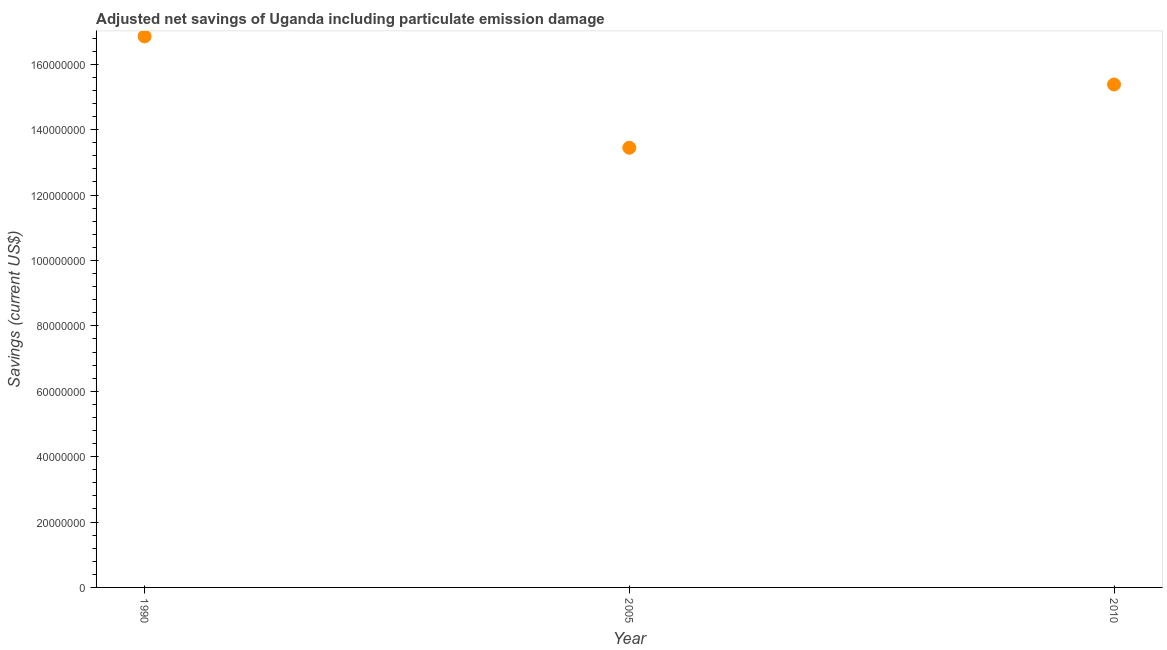What is the adjusted net savings in 2010?
Your answer should be very brief. 1.54e+08. Across all years, what is the maximum adjusted net savings?
Offer a very short reply. 1.69e+08. Across all years, what is the minimum adjusted net savings?
Your answer should be compact. 1.34e+08. In which year was the adjusted net savings minimum?
Keep it short and to the point. 2005. What is the sum of the adjusted net savings?
Your response must be concise. 4.57e+08. What is the difference between the adjusted net savings in 1990 and 2010?
Keep it short and to the point. 1.47e+07. What is the average adjusted net savings per year?
Your answer should be very brief. 1.52e+08. What is the median adjusted net savings?
Give a very brief answer. 1.54e+08. What is the ratio of the adjusted net savings in 1990 to that in 2005?
Provide a short and direct response. 1.25. Is the adjusted net savings in 1990 less than that in 2005?
Your response must be concise. No. Is the difference between the adjusted net savings in 1990 and 2005 greater than the difference between any two years?
Offer a terse response. Yes. What is the difference between the highest and the second highest adjusted net savings?
Provide a succinct answer. 1.47e+07. Is the sum of the adjusted net savings in 1990 and 2005 greater than the maximum adjusted net savings across all years?
Make the answer very short. Yes. What is the difference between the highest and the lowest adjusted net savings?
Offer a very short reply. 3.41e+07. Does the adjusted net savings monotonically increase over the years?
Give a very brief answer. No. What is the difference between two consecutive major ticks on the Y-axis?
Your answer should be compact. 2.00e+07. What is the title of the graph?
Provide a succinct answer. Adjusted net savings of Uganda including particulate emission damage. What is the label or title of the X-axis?
Provide a succinct answer. Year. What is the label or title of the Y-axis?
Your answer should be compact. Savings (current US$). What is the Savings (current US$) in 1990?
Provide a short and direct response. 1.69e+08. What is the Savings (current US$) in 2005?
Offer a very short reply. 1.34e+08. What is the Savings (current US$) in 2010?
Offer a terse response. 1.54e+08. What is the difference between the Savings (current US$) in 1990 and 2005?
Your response must be concise. 3.41e+07. What is the difference between the Savings (current US$) in 1990 and 2010?
Keep it short and to the point. 1.47e+07. What is the difference between the Savings (current US$) in 2005 and 2010?
Your response must be concise. -1.93e+07. What is the ratio of the Savings (current US$) in 1990 to that in 2005?
Ensure brevity in your answer.  1.25. What is the ratio of the Savings (current US$) in 1990 to that in 2010?
Keep it short and to the point. 1.1. What is the ratio of the Savings (current US$) in 2005 to that in 2010?
Your answer should be very brief. 0.87. 